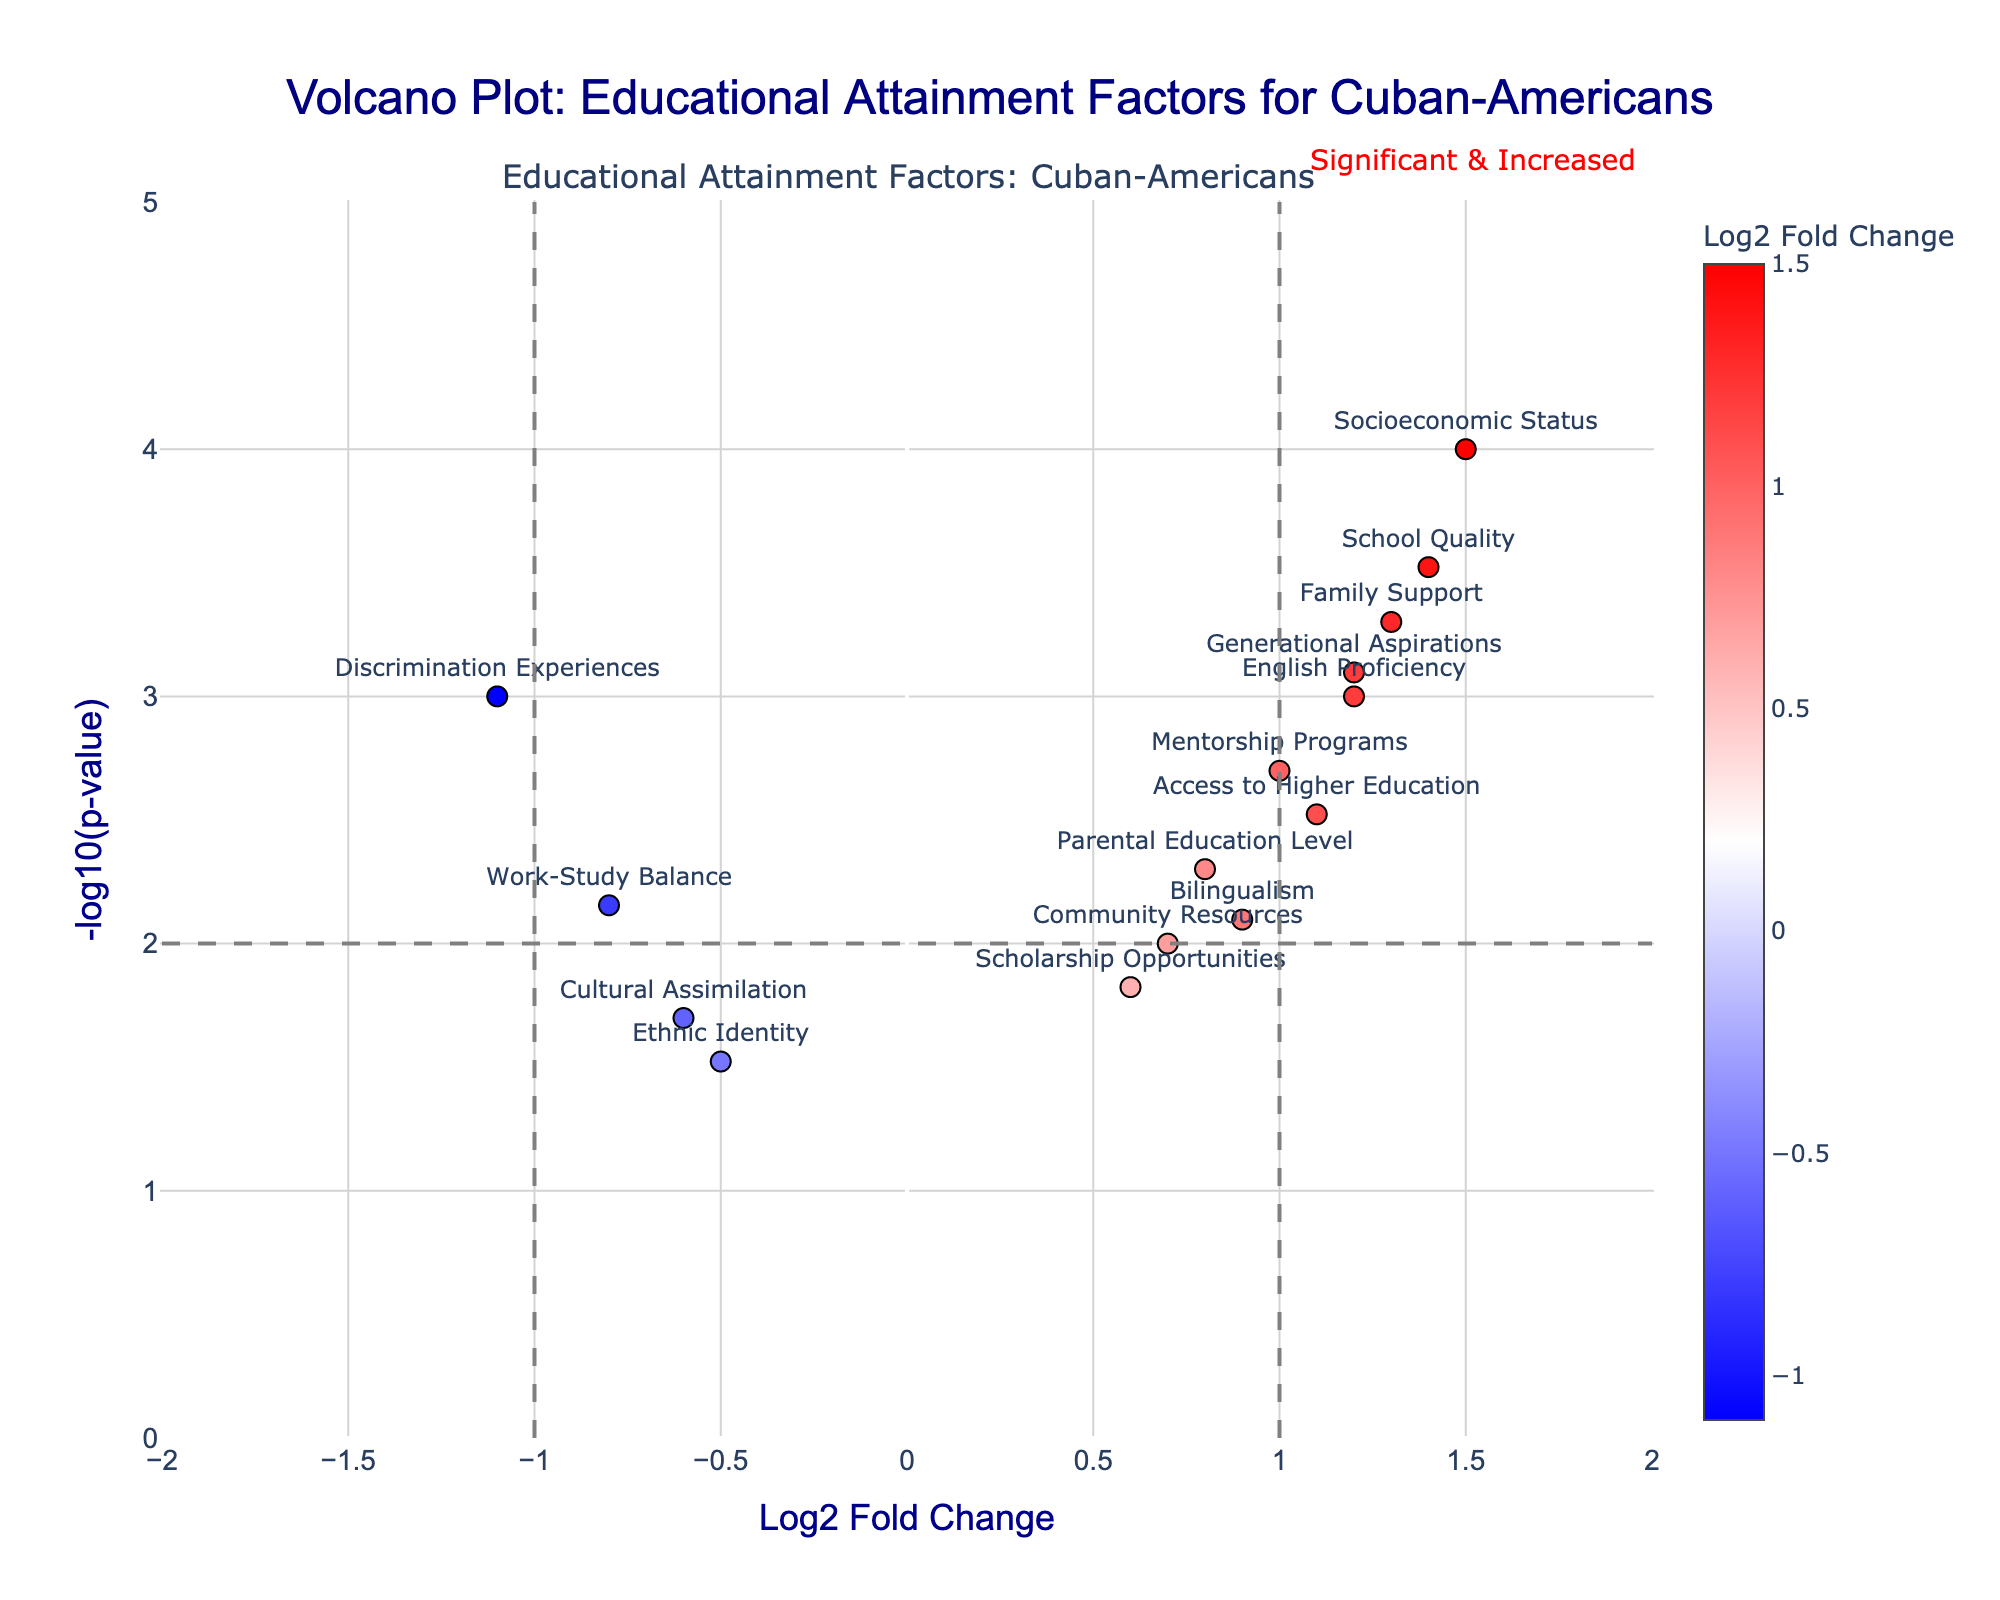What's the title of the plot? The title is displayed prominently at the top of the plot in a large font. It sets the context for the data visualization.
Answer: Volcano Plot: Educational Attainment Factors for Cuban-Americans What are the axes labels of the plot? The x-axis is labeled 'Log2 Fold Change', which indicates the logarithmic fold change of each factor. The y-axis is labeled '-log10(p-value)', showing the negative logarithm of the p-value for each factor.
Answer: Log2 Fold Change; -log10(p-value) How many educational attainment factors have a Log2 Fold Change greater than 1.0? By visually inspecting the x-axis, we can count the number of points that lie to the right of the vertical line at Log2 Fold Change = 1.0.
Answer: 6 What factor has the highest -log10(p-value) and what is its value? By looking at the y-axis, we can find the highest point, which represents the largest -log10(p-value). Hover text or labels provide the specific value and factor.
Answer: Socioeconomic Status, ~4 Which factor shows the greatest negative impact on educational attainment? The factor with the highest negative Log2 Fold Change value indicates the greatest negative impact. This is found by identifying the leftmost point on the x-axis.
Answer: Discrimination Experiences Compare the Log2 Fold Change values of 'Family Support' and 'Cultural Assimilation'. Which is higher? By locating these two factors on the plot and comparing their x-axis positions, we can determine that the Log2 Fold Change of 'Family Support' (1.3) is higher than 'Cultural Assimilation' (-0.6).
Answer: Family Support What does a point with a high -log10(p-value) and high positive Log2 Fold Change indicate? A high -log10(p-value) indicates a statistically significant result, and a high positive Log2 Fold Change suggests a strong positive impact on educational attainment. Therefore, such a point indicates a factor with a statistically significant, strong positive effect.
Answer: Statistically significant, strong positive impact Identify all factors with a -log10(p-value) greater than 2 and describe their trend in terms of educational attainment. Points above the horizontal line at -log10(p-value) = 2 have statistically significant p-values. By inspecting these points:
- Socioeconomic Status (positive impact)
- School Quality (positive impact)
- Family Support (positive impact)
Each of these points represents factors with significant influences on educational attainment.
Answer: Socioeconomic Status, School Quality, Family Support; All have a positive trend Which factor has the closest Log2 Fold Change to 0 and is it statistically significant? Find the factor nearest to Log2 Fold Change = 0 on the x-axis. Then check its -log10(p-value) to determine significance (a significantly high -log10(p-value) typically means it's significant).
Answer: Community Resources; Not statistically significant 